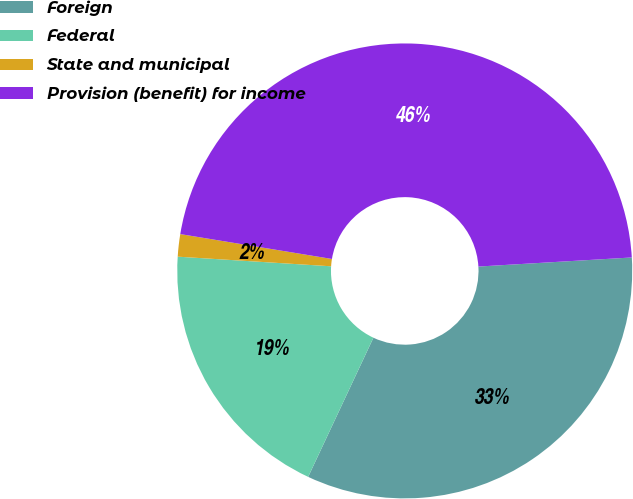Convert chart. <chart><loc_0><loc_0><loc_500><loc_500><pie_chart><fcel>Foreign<fcel>Federal<fcel>State and municipal<fcel>Provision (benefit) for income<nl><fcel>32.92%<fcel>19.02%<fcel>1.59%<fcel>46.47%<nl></chart> 